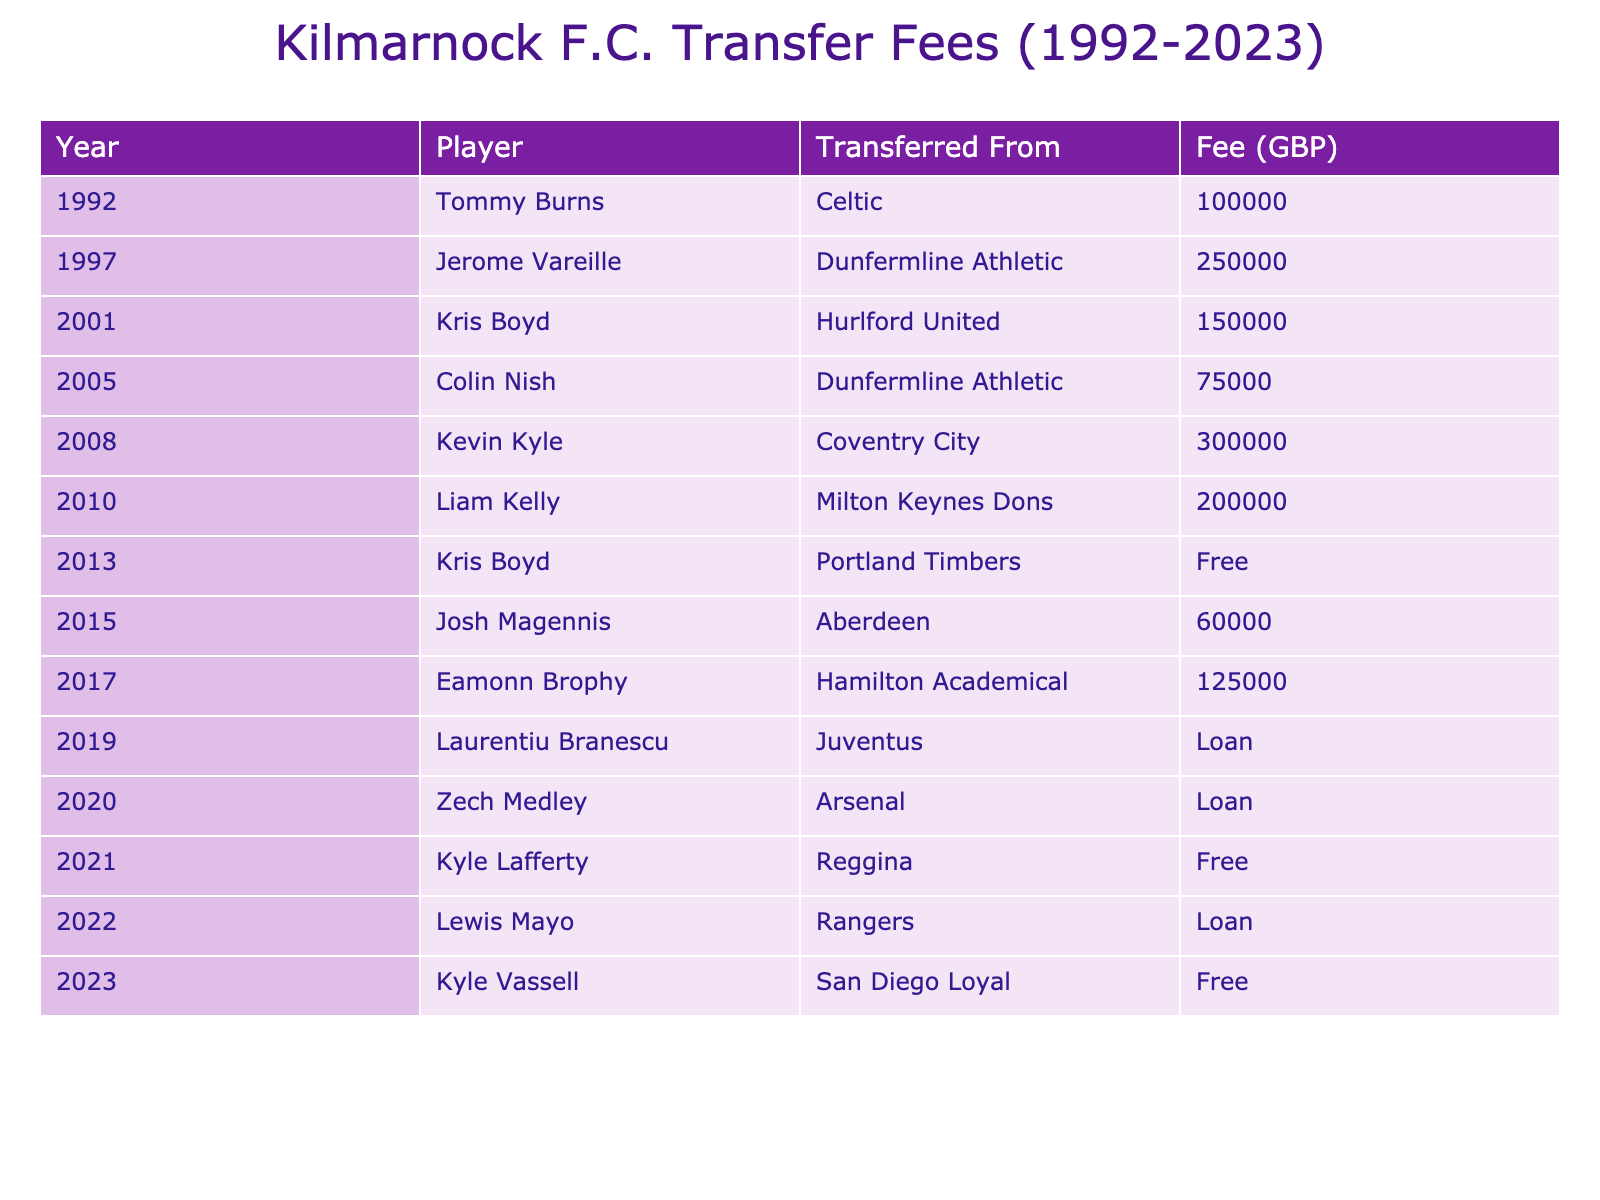What is the highest transfer fee paid by Kilmarnock F.C.? The table shows that the highest transfer fee paid was for Kevin Kyle at 300,000 GBP.
Answer: 300,000 GBP Who was transferred from Arsenal to Kilmarnock F.C.? According to the table, Zech Medley was transferred from Arsenal on loan.
Answer: Zech Medley How many players were acquired for a free transfer? The table lists three players acquired for free: Kris Boyd, Kyle Lafferty, and Kyle Vassell.
Answer: 3 What is the average transfer fee paid over the years listed in the table? The total of transfer fees is 1,775,000 GBP (including free and loan transfers is 1,775,000 and 0, respectively), and there are 13 entries considered (excluding loans), so the average is 1,775,000 / 10.
Answer: 177,500 GBP Was there any transfer from Juventus to Kilmarnock F.C.? The table indicates that Laurentiu Branescu was loaned from Juventus, so the answer is yes.
Answer: Yes How does the sum of all transfer fees compare between players transferred from Scottish clubs and those from other countries? Players from Scottish clubs (Tommy Burns, Jerome Vareille, Colin Nish, and Josh Magennis) sum to 415,000 GBP, while those from other countries (Kevin Kyle, Liam Kelly, Eamonn Brophy, etc.) total 1,290,000 GBP, indicating higher fees from foreign clubs.
Answer: Higher from foreign clubs Which year saw the lowest transfer fee paid? Looking at the table, the lowest transfer fee paid was 60,000 GBP for Josh Magennis in 2015.
Answer: 60,000 GBP What percentage of the total number of player transfers were loans? The table shows 4 loan transfers out of a total of 13 entries, so the percentage is (4/13) * 100 = 30.77%.
Answer: 30.77% In which year was the transfer fee of 200,000 GBP paid? The table shows that the transfer fee of 200,000 GBP was paid for Liam Kelly in 2010.
Answer: 2010 How many players were transferred between 2000 and 2010? From the table, four players were transferred in that decade: Kris Boyd, Colin Nish, Kevin Kyle, and Liam Kelly.
Answer: 4 What is the difference in transfer fees between the highest and lowest transfer fees paid? The highest fee is 300,000 GBP (for Kevin Kyle) and the lowest is 60,000 GBP (for Josh Magennis), so the difference is 300,000 - 60,000 = 240,000 GBP.
Answer: 240,000 GBP 